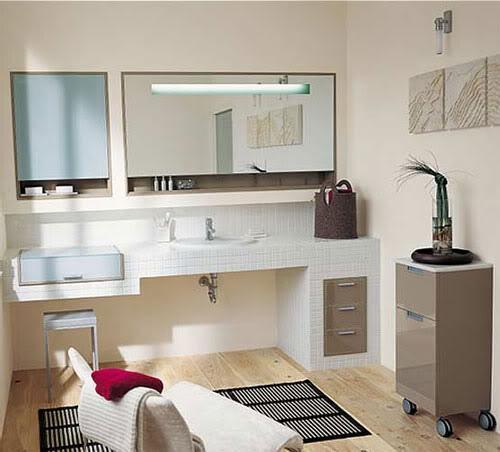How many mirrors are there?
Give a very brief answer. 2. 